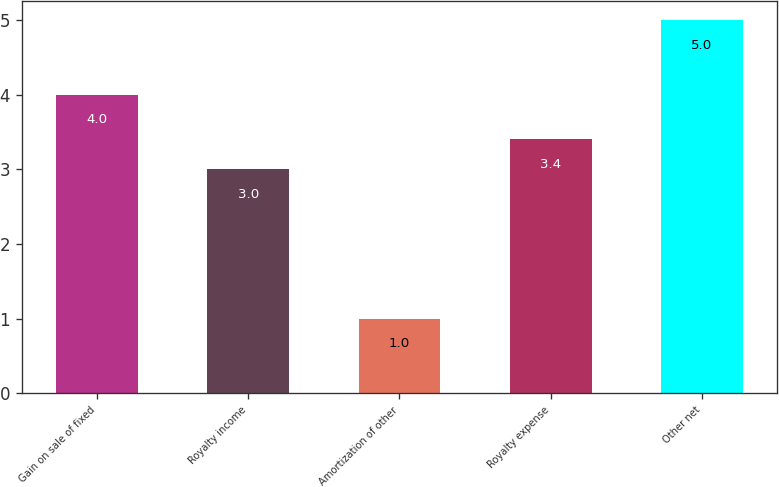Convert chart to OTSL. <chart><loc_0><loc_0><loc_500><loc_500><bar_chart><fcel>Gain on sale of fixed<fcel>Royalty income<fcel>Amortization of other<fcel>Royalty expense<fcel>Other net<nl><fcel>4<fcel>3<fcel>1<fcel>3.4<fcel>5<nl></chart> 